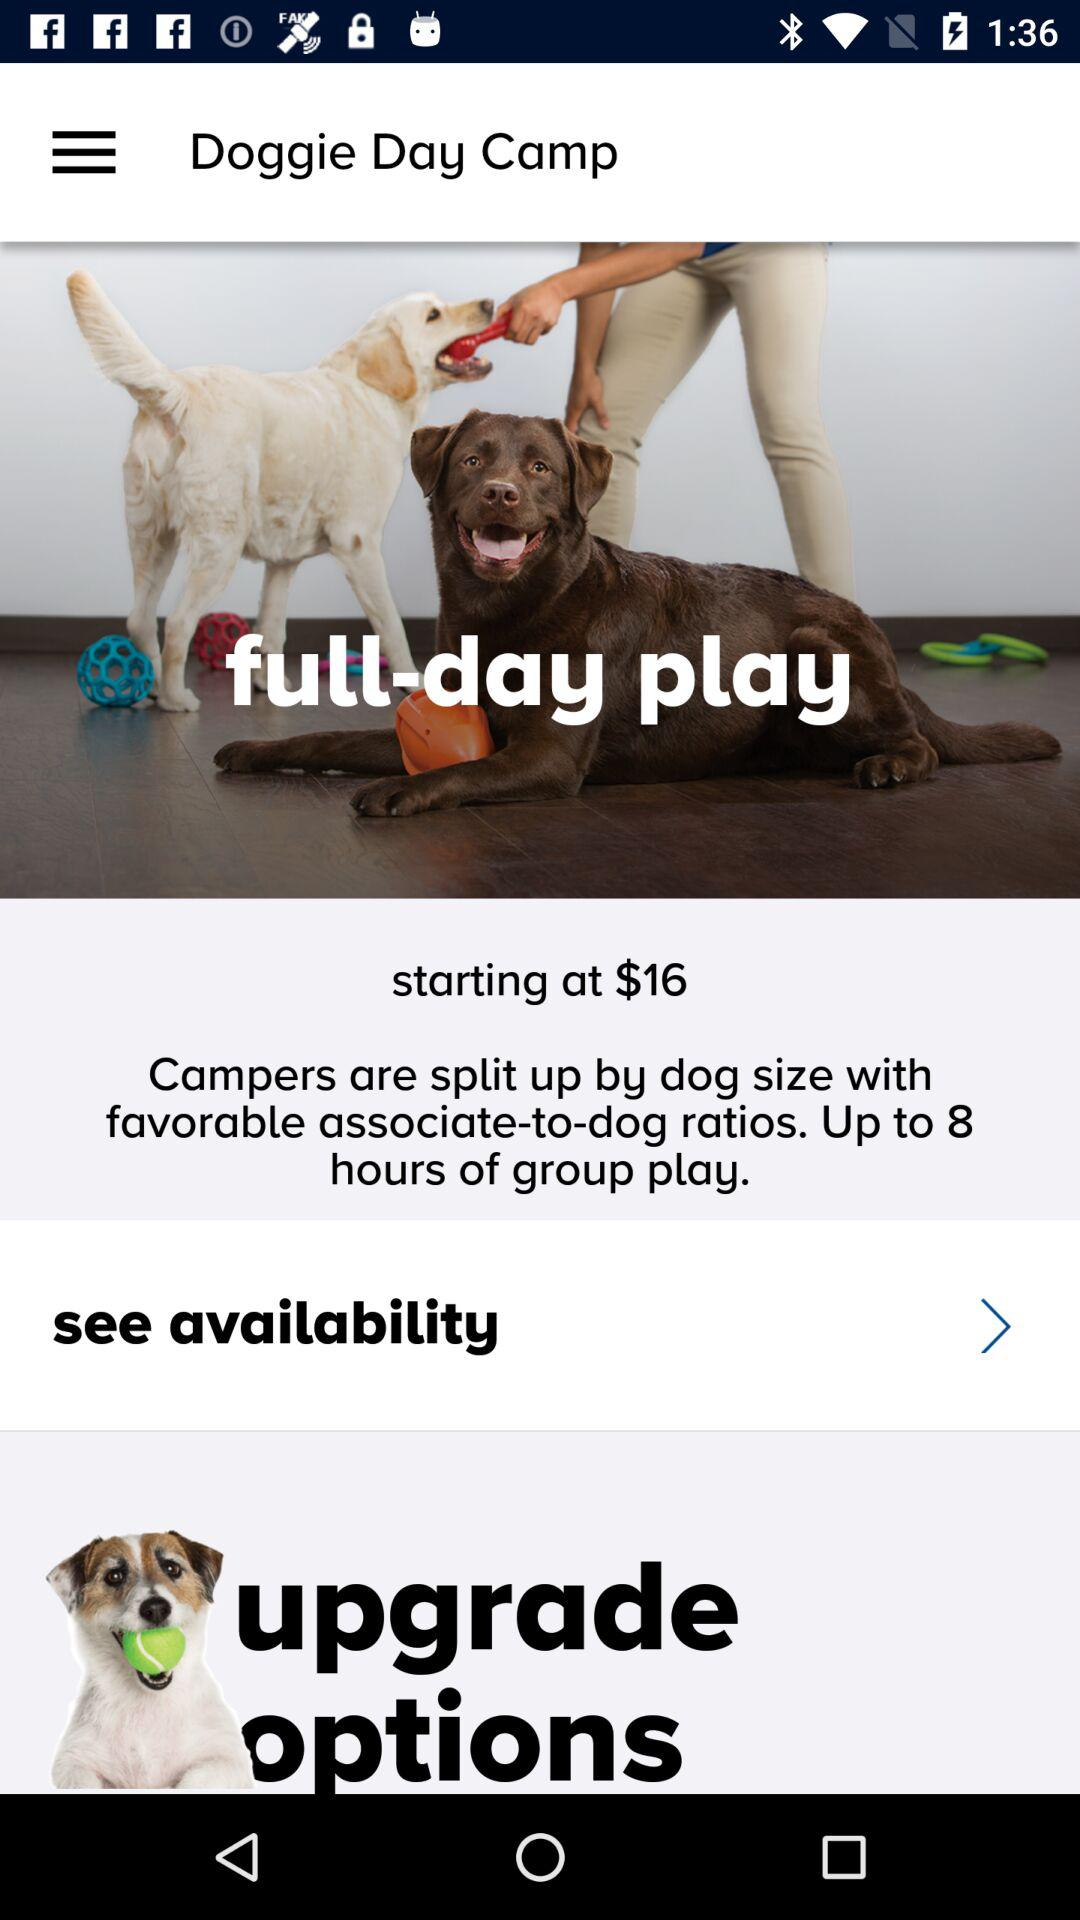What is the time duration for the group play? The time duration is up to 8 hours. 